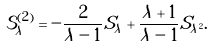Convert formula to latex. <formula><loc_0><loc_0><loc_500><loc_500>\mathcal { S } _ { \lambda } ^ { ( 2 ) } = - \frac { 2 } { \lambda - 1 } S _ { \lambda } + \frac { \lambda + 1 } { \lambda - 1 } S _ { \lambda ^ { 2 } } .</formula> 